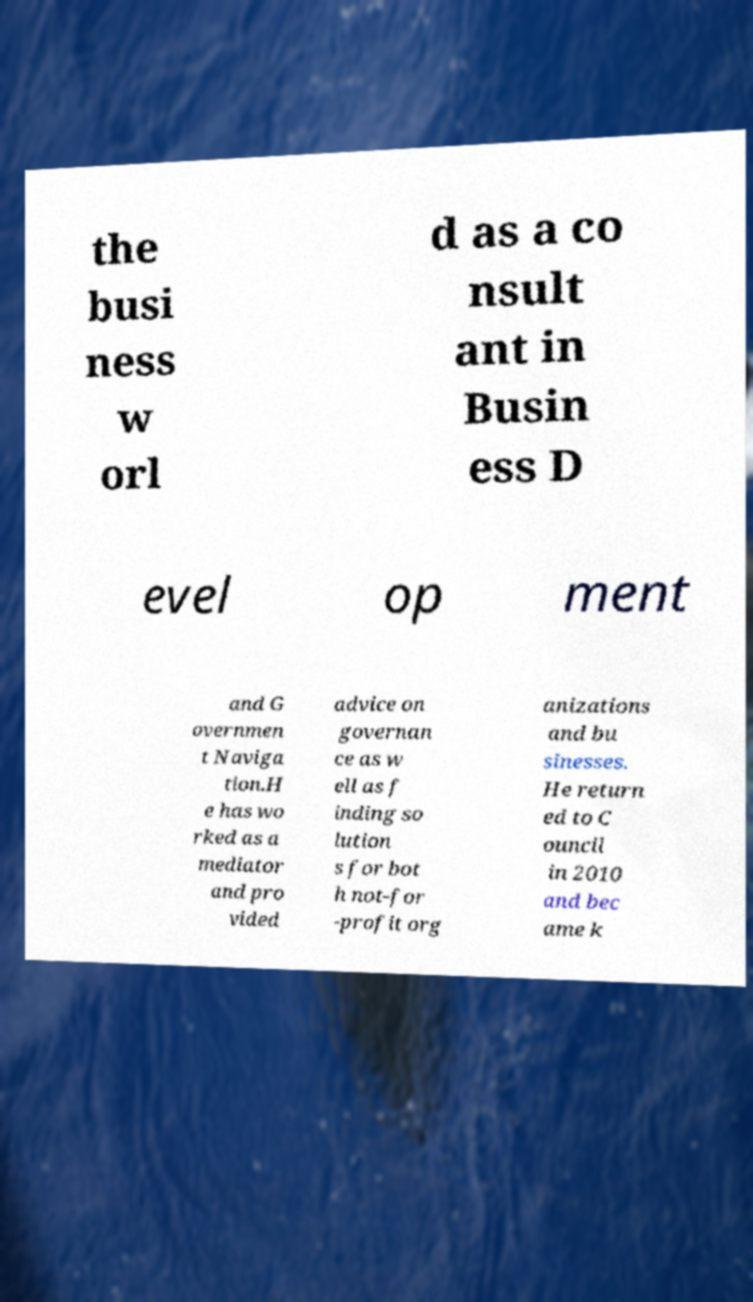Can you read and provide the text displayed in the image?This photo seems to have some interesting text. Can you extract and type it out for me? the busi ness w orl d as a co nsult ant in Busin ess D evel op ment and G overnmen t Naviga tion.H e has wo rked as a mediator and pro vided advice on governan ce as w ell as f inding so lution s for bot h not-for -profit org anizations and bu sinesses. He return ed to C ouncil in 2010 and bec ame k 